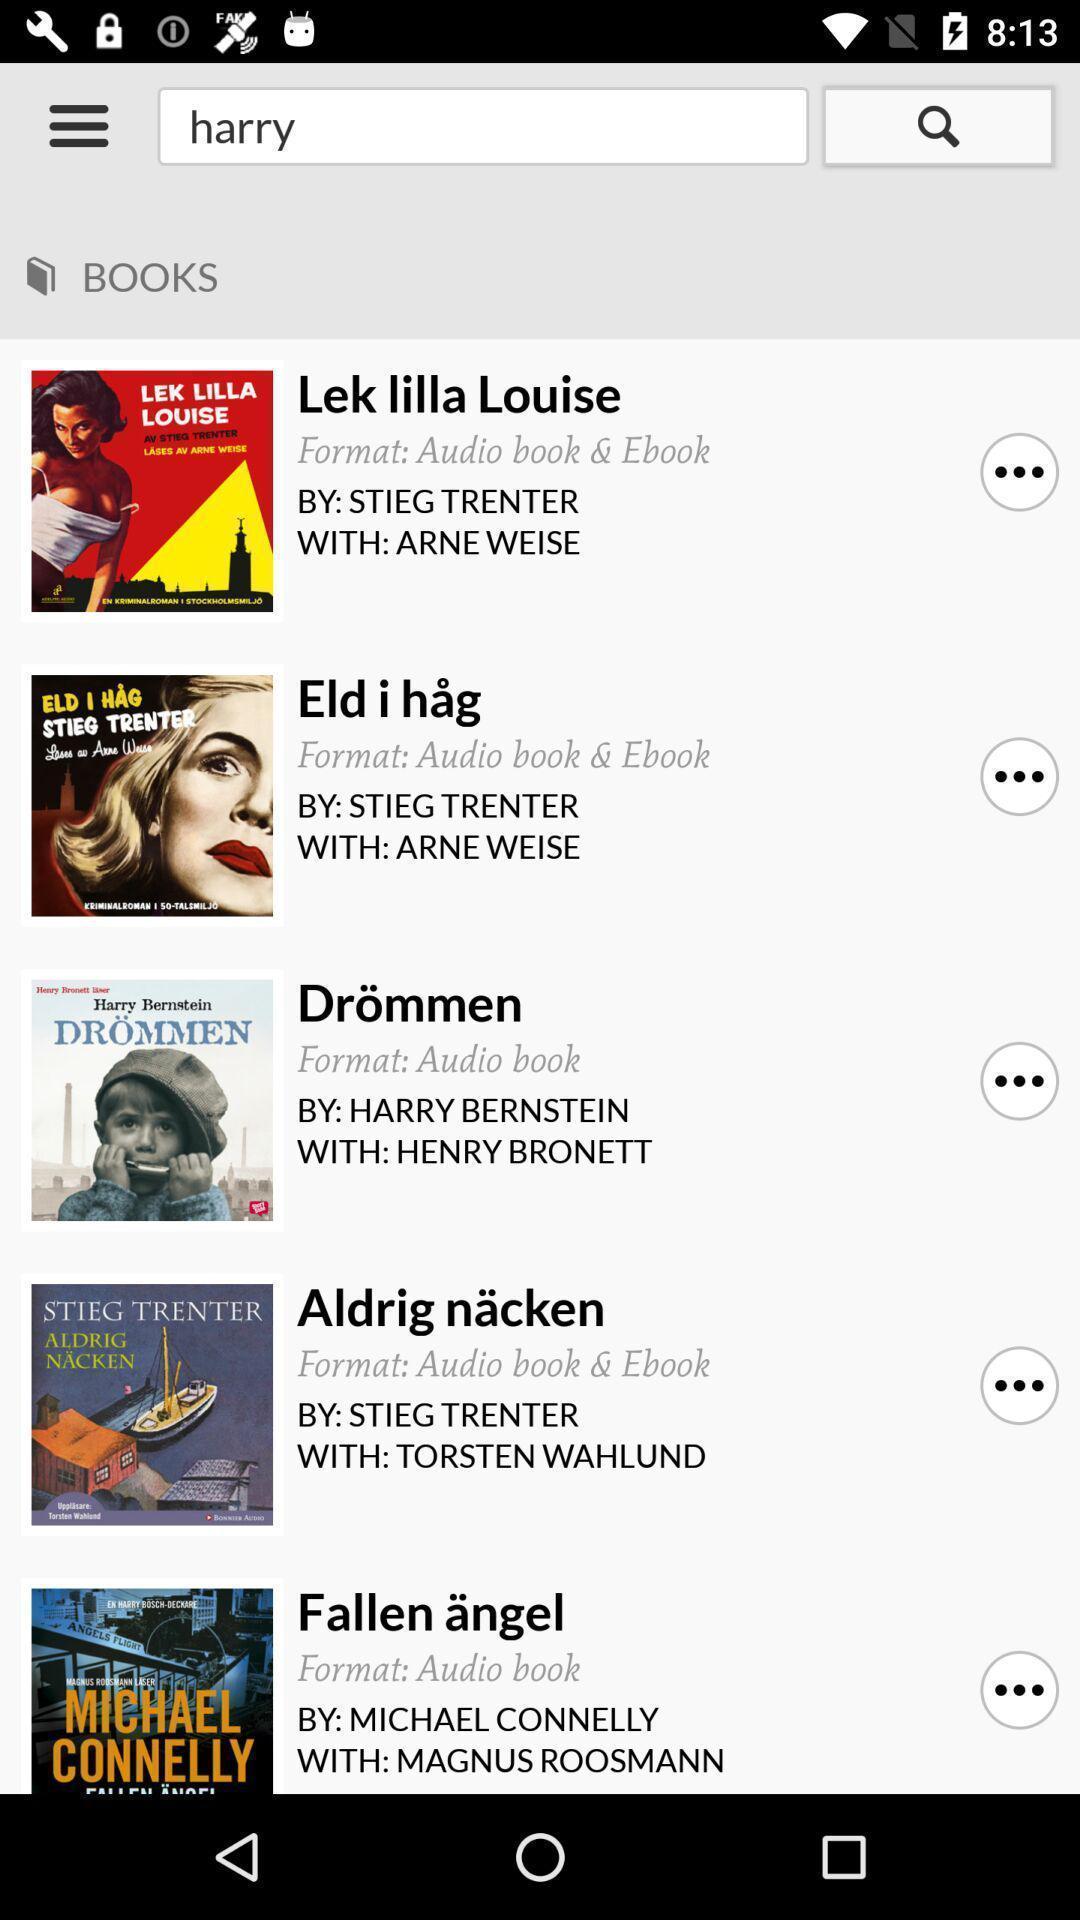Describe the content in this image. Search option to read book. 